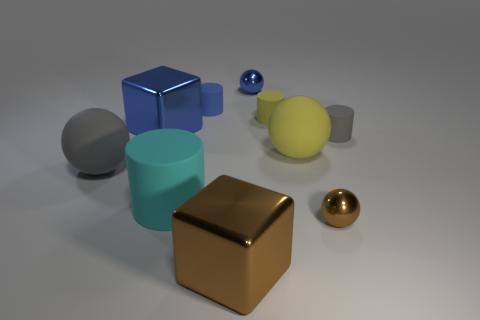Are there fewer small yellow rubber cylinders right of the big blue metallic thing than cylinders that are on the left side of the large yellow ball?
Offer a terse response. Yes. There is a big metal thing that is behind the big cyan rubber cylinder; what shape is it?
Your response must be concise. Cube. What number of other things are made of the same material as the tiny yellow cylinder?
Offer a very short reply. 5. There is a tiny gray rubber object; does it have the same shape as the small blue thing behind the blue cylinder?
Offer a very short reply. No. There is a cyan object that is the same material as the small yellow cylinder; what shape is it?
Your answer should be compact. Cylinder. Are there more rubber cylinders in front of the brown shiny cube than cylinders that are behind the tiny yellow cylinder?
Give a very brief answer. No. How many objects are large cyan rubber things or small yellow cylinders?
Ensure brevity in your answer.  2. What number of other things are the same color as the big cylinder?
Offer a very short reply. 0. The yellow rubber object that is the same size as the gray matte ball is what shape?
Keep it short and to the point. Sphere. There is a tiny shiny sphere behind the blue matte cylinder; what color is it?
Make the answer very short. Blue. 